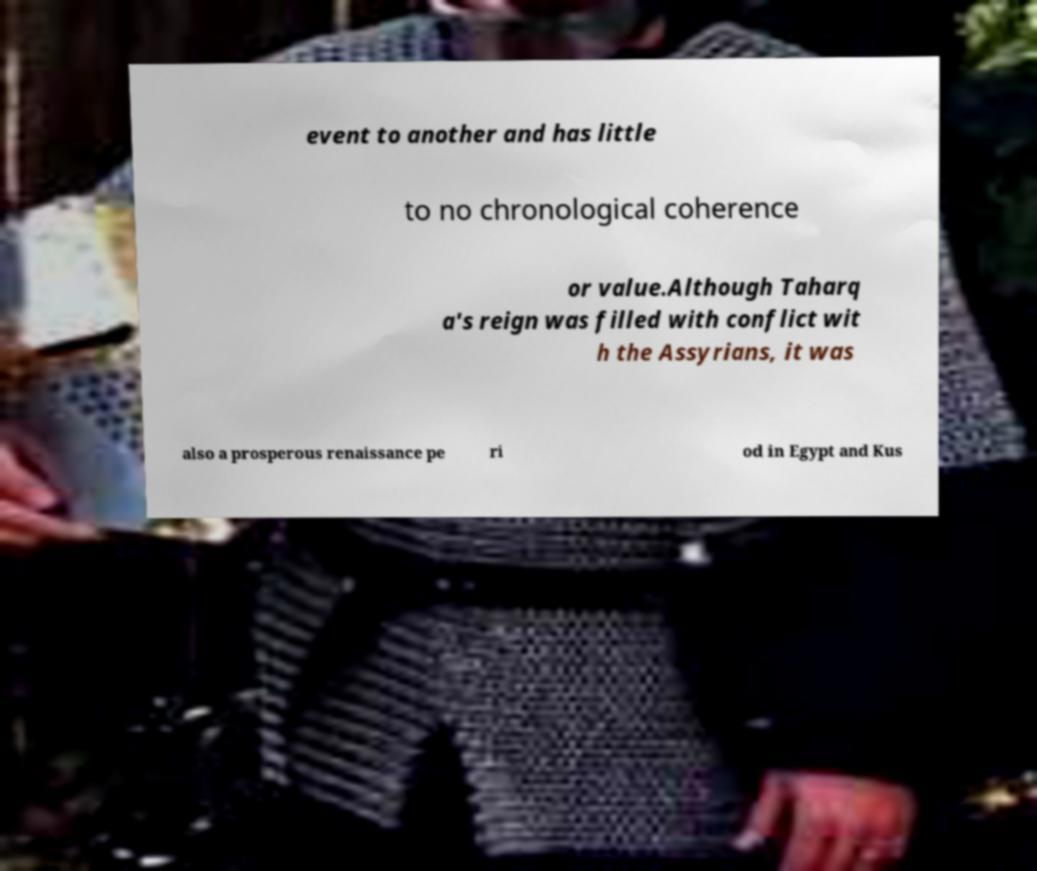Can you read and provide the text displayed in the image?This photo seems to have some interesting text. Can you extract and type it out for me? event to another and has little to no chronological coherence or value.Although Taharq a's reign was filled with conflict wit h the Assyrians, it was also a prosperous renaissance pe ri od in Egypt and Kus 